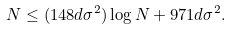Convert formula to latex. <formula><loc_0><loc_0><loc_500><loc_500>N \leq ( 1 4 8 d \sigma ^ { 2 } ) \log N + 9 7 1 d \sigma ^ { 2 } .</formula> 